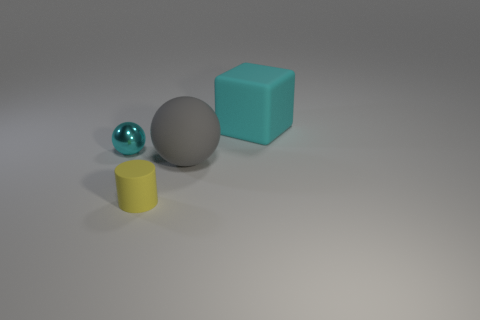Add 1 yellow metal cubes. How many objects exist? 5 Subtract all cylinders. How many objects are left? 3 Subtract 0 brown cylinders. How many objects are left? 4 Subtract all small cyan blocks. Subtract all large cyan rubber things. How many objects are left? 3 Add 2 balls. How many balls are left? 4 Add 3 yellow matte things. How many yellow matte things exist? 4 